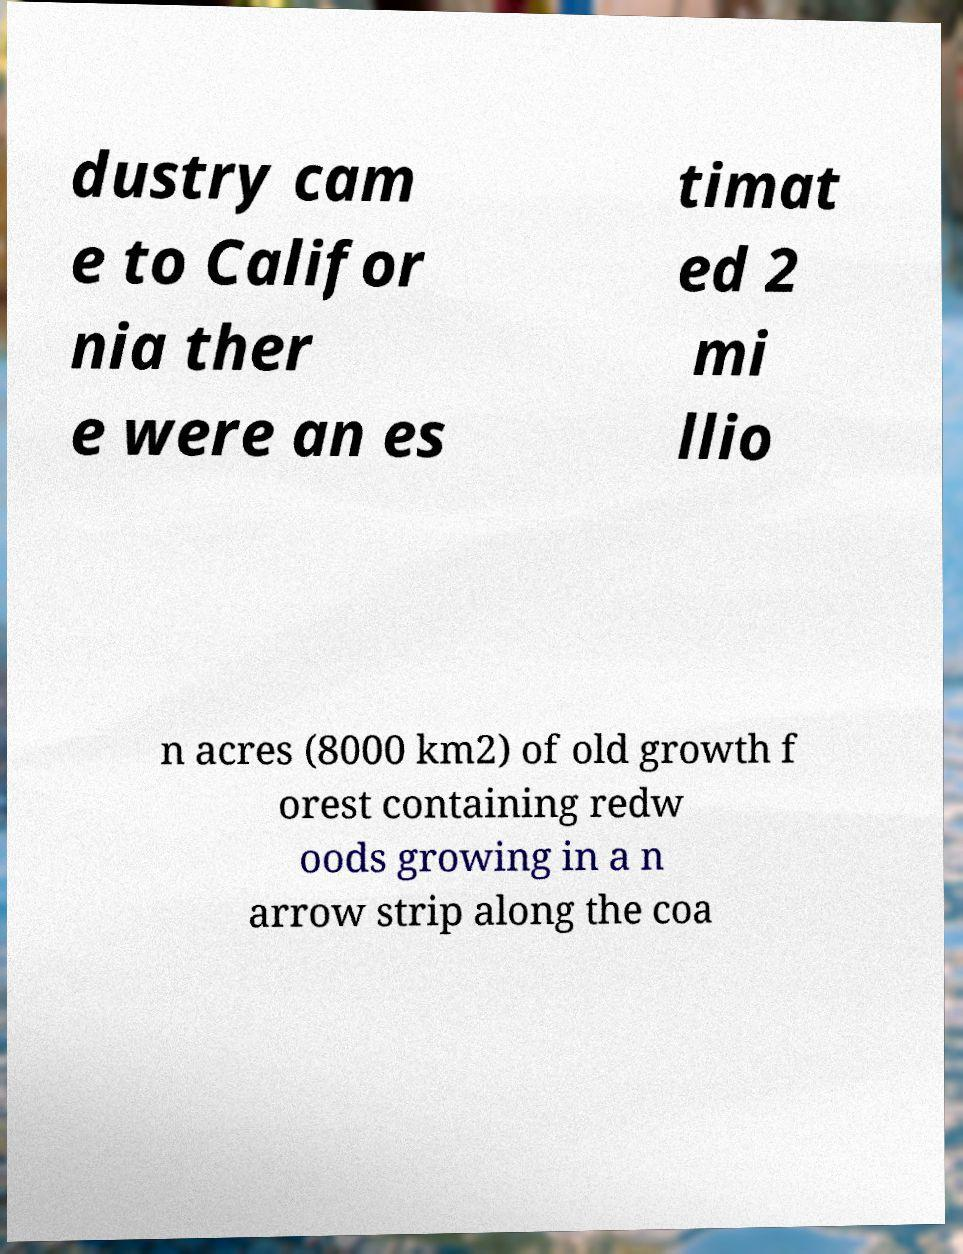Could you extract and type out the text from this image? dustry cam e to Califor nia ther e were an es timat ed 2 mi llio n acres (8000 km2) of old growth f orest containing redw oods growing in a n arrow strip along the coa 